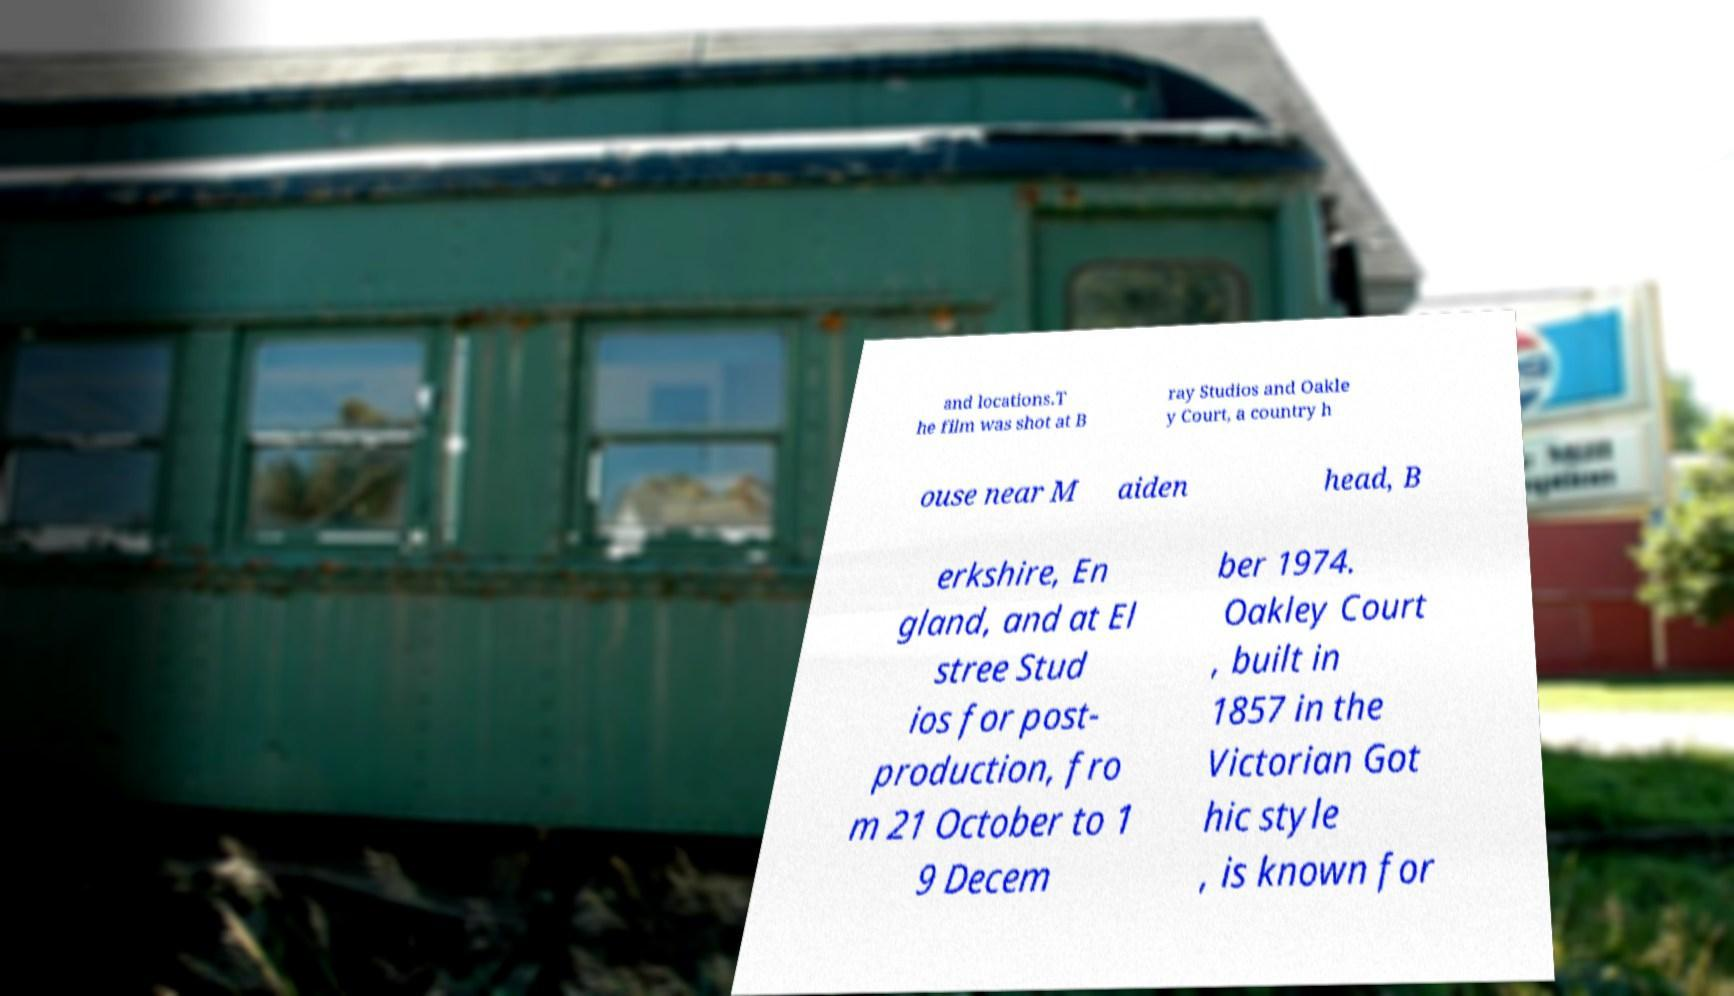Could you assist in decoding the text presented in this image and type it out clearly? and locations.T he film was shot at B ray Studios and Oakle y Court, a country h ouse near M aiden head, B erkshire, En gland, and at El stree Stud ios for post- production, fro m 21 October to 1 9 Decem ber 1974. Oakley Court , built in 1857 in the Victorian Got hic style , is known for 